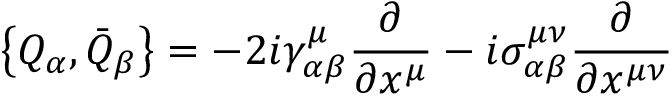Convert formula to latex. <formula><loc_0><loc_0><loc_500><loc_500>\left \{ Q _ { \alpha } , \bar { Q } _ { \beta } \right \} = - 2 i \gamma _ { \alpha \beta } ^ { \mu } \frac { \partial } { \partial x ^ { \mu } } - i \sigma _ { \alpha \beta } ^ { \mu \nu } \frac { \partial } { \partial x ^ { \mu \nu } }</formula> 